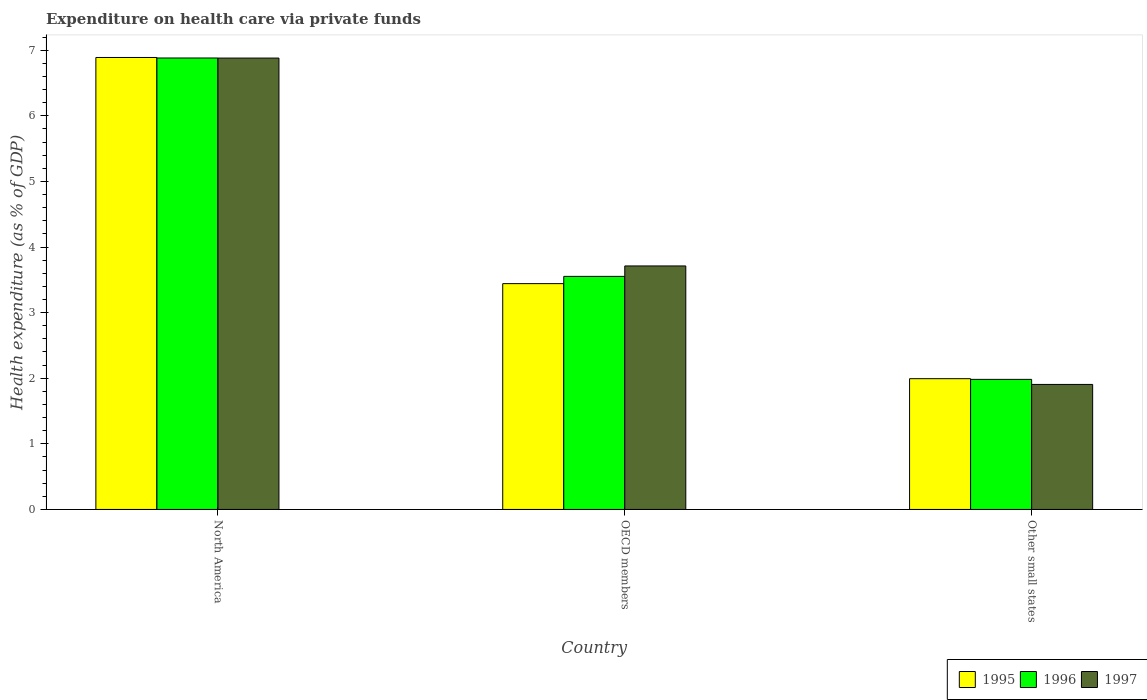How many different coloured bars are there?
Offer a terse response. 3. How many groups of bars are there?
Keep it short and to the point. 3. Are the number of bars per tick equal to the number of legend labels?
Provide a succinct answer. Yes. In how many cases, is the number of bars for a given country not equal to the number of legend labels?
Your answer should be compact. 0. What is the expenditure made on health care in 1996 in OECD members?
Offer a terse response. 3.55. Across all countries, what is the maximum expenditure made on health care in 1995?
Offer a very short reply. 6.89. Across all countries, what is the minimum expenditure made on health care in 1995?
Give a very brief answer. 1.99. In which country was the expenditure made on health care in 1995 minimum?
Ensure brevity in your answer.  Other small states. What is the total expenditure made on health care in 1997 in the graph?
Your answer should be compact. 12.5. What is the difference between the expenditure made on health care in 1995 in OECD members and that in Other small states?
Provide a succinct answer. 1.45. What is the difference between the expenditure made on health care in 1997 in North America and the expenditure made on health care in 1996 in OECD members?
Provide a succinct answer. 3.33. What is the average expenditure made on health care in 1997 per country?
Your response must be concise. 4.17. What is the difference between the expenditure made on health care of/in 1997 and expenditure made on health care of/in 1995 in Other small states?
Offer a terse response. -0.09. What is the ratio of the expenditure made on health care in 1995 in OECD members to that in Other small states?
Keep it short and to the point. 1.73. Is the expenditure made on health care in 1996 in North America less than that in Other small states?
Provide a succinct answer. No. Is the difference between the expenditure made on health care in 1997 in North America and Other small states greater than the difference between the expenditure made on health care in 1995 in North America and Other small states?
Your answer should be compact. Yes. What is the difference between the highest and the second highest expenditure made on health care in 1997?
Make the answer very short. -1.81. What is the difference between the highest and the lowest expenditure made on health care in 1997?
Provide a succinct answer. 4.97. In how many countries, is the expenditure made on health care in 1996 greater than the average expenditure made on health care in 1996 taken over all countries?
Offer a very short reply. 1. What does the 2nd bar from the left in North America represents?
Offer a very short reply. 1996. What does the 2nd bar from the right in OECD members represents?
Ensure brevity in your answer.  1996. Is it the case that in every country, the sum of the expenditure made on health care in 1995 and expenditure made on health care in 1996 is greater than the expenditure made on health care in 1997?
Your response must be concise. Yes. How many bars are there?
Give a very brief answer. 9. Are all the bars in the graph horizontal?
Ensure brevity in your answer.  No. How many countries are there in the graph?
Your answer should be compact. 3. What is the difference between two consecutive major ticks on the Y-axis?
Keep it short and to the point. 1. Are the values on the major ticks of Y-axis written in scientific E-notation?
Give a very brief answer. No. Does the graph contain any zero values?
Your answer should be compact. No. Does the graph contain grids?
Give a very brief answer. No. How are the legend labels stacked?
Your answer should be compact. Horizontal. What is the title of the graph?
Make the answer very short. Expenditure on health care via private funds. Does "2013" appear as one of the legend labels in the graph?
Keep it short and to the point. No. What is the label or title of the X-axis?
Provide a succinct answer. Country. What is the label or title of the Y-axis?
Your answer should be very brief. Health expenditure (as % of GDP). What is the Health expenditure (as % of GDP) in 1995 in North America?
Offer a very short reply. 6.89. What is the Health expenditure (as % of GDP) in 1996 in North America?
Make the answer very short. 6.88. What is the Health expenditure (as % of GDP) of 1997 in North America?
Keep it short and to the point. 6.88. What is the Health expenditure (as % of GDP) in 1995 in OECD members?
Provide a short and direct response. 3.44. What is the Health expenditure (as % of GDP) of 1996 in OECD members?
Make the answer very short. 3.55. What is the Health expenditure (as % of GDP) in 1997 in OECD members?
Your answer should be compact. 3.71. What is the Health expenditure (as % of GDP) in 1995 in Other small states?
Your answer should be compact. 1.99. What is the Health expenditure (as % of GDP) in 1996 in Other small states?
Ensure brevity in your answer.  1.98. What is the Health expenditure (as % of GDP) in 1997 in Other small states?
Provide a succinct answer. 1.91. Across all countries, what is the maximum Health expenditure (as % of GDP) of 1995?
Provide a short and direct response. 6.89. Across all countries, what is the maximum Health expenditure (as % of GDP) of 1996?
Ensure brevity in your answer.  6.88. Across all countries, what is the maximum Health expenditure (as % of GDP) in 1997?
Make the answer very short. 6.88. Across all countries, what is the minimum Health expenditure (as % of GDP) of 1995?
Give a very brief answer. 1.99. Across all countries, what is the minimum Health expenditure (as % of GDP) of 1996?
Make the answer very short. 1.98. Across all countries, what is the minimum Health expenditure (as % of GDP) of 1997?
Provide a succinct answer. 1.91. What is the total Health expenditure (as % of GDP) of 1995 in the graph?
Offer a terse response. 12.32. What is the total Health expenditure (as % of GDP) in 1996 in the graph?
Provide a succinct answer. 12.42. What is the total Health expenditure (as % of GDP) of 1997 in the graph?
Provide a short and direct response. 12.5. What is the difference between the Health expenditure (as % of GDP) in 1995 in North America and that in OECD members?
Provide a succinct answer. 3.45. What is the difference between the Health expenditure (as % of GDP) in 1996 in North America and that in OECD members?
Make the answer very short. 3.33. What is the difference between the Health expenditure (as % of GDP) of 1997 in North America and that in OECD members?
Offer a very short reply. 3.17. What is the difference between the Health expenditure (as % of GDP) in 1995 in North America and that in Other small states?
Offer a very short reply. 4.9. What is the difference between the Health expenditure (as % of GDP) in 1996 in North America and that in Other small states?
Provide a succinct answer. 4.9. What is the difference between the Health expenditure (as % of GDP) in 1997 in North America and that in Other small states?
Your response must be concise. 4.97. What is the difference between the Health expenditure (as % of GDP) of 1995 in OECD members and that in Other small states?
Your response must be concise. 1.45. What is the difference between the Health expenditure (as % of GDP) of 1996 in OECD members and that in Other small states?
Ensure brevity in your answer.  1.57. What is the difference between the Health expenditure (as % of GDP) of 1997 in OECD members and that in Other small states?
Provide a succinct answer. 1.81. What is the difference between the Health expenditure (as % of GDP) in 1995 in North America and the Health expenditure (as % of GDP) in 1996 in OECD members?
Provide a succinct answer. 3.34. What is the difference between the Health expenditure (as % of GDP) in 1995 in North America and the Health expenditure (as % of GDP) in 1997 in OECD members?
Your answer should be compact. 3.18. What is the difference between the Health expenditure (as % of GDP) of 1996 in North America and the Health expenditure (as % of GDP) of 1997 in OECD members?
Your response must be concise. 3.17. What is the difference between the Health expenditure (as % of GDP) of 1995 in North America and the Health expenditure (as % of GDP) of 1996 in Other small states?
Your answer should be compact. 4.91. What is the difference between the Health expenditure (as % of GDP) in 1995 in North America and the Health expenditure (as % of GDP) in 1997 in Other small states?
Your answer should be very brief. 4.98. What is the difference between the Health expenditure (as % of GDP) in 1996 in North America and the Health expenditure (as % of GDP) in 1997 in Other small states?
Ensure brevity in your answer.  4.98. What is the difference between the Health expenditure (as % of GDP) of 1995 in OECD members and the Health expenditure (as % of GDP) of 1996 in Other small states?
Your answer should be compact. 1.46. What is the difference between the Health expenditure (as % of GDP) of 1995 in OECD members and the Health expenditure (as % of GDP) of 1997 in Other small states?
Keep it short and to the point. 1.54. What is the difference between the Health expenditure (as % of GDP) in 1996 in OECD members and the Health expenditure (as % of GDP) in 1997 in Other small states?
Keep it short and to the point. 1.65. What is the average Health expenditure (as % of GDP) of 1995 per country?
Give a very brief answer. 4.11. What is the average Health expenditure (as % of GDP) of 1996 per country?
Keep it short and to the point. 4.14. What is the average Health expenditure (as % of GDP) in 1997 per country?
Your answer should be very brief. 4.17. What is the difference between the Health expenditure (as % of GDP) of 1995 and Health expenditure (as % of GDP) of 1996 in North America?
Offer a terse response. 0.01. What is the difference between the Health expenditure (as % of GDP) in 1995 and Health expenditure (as % of GDP) in 1997 in North America?
Offer a very short reply. 0.01. What is the difference between the Health expenditure (as % of GDP) in 1996 and Health expenditure (as % of GDP) in 1997 in North America?
Make the answer very short. 0. What is the difference between the Health expenditure (as % of GDP) in 1995 and Health expenditure (as % of GDP) in 1996 in OECD members?
Your response must be concise. -0.11. What is the difference between the Health expenditure (as % of GDP) of 1995 and Health expenditure (as % of GDP) of 1997 in OECD members?
Provide a succinct answer. -0.27. What is the difference between the Health expenditure (as % of GDP) of 1996 and Health expenditure (as % of GDP) of 1997 in OECD members?
Keep it short and to the point. -0.16. What is the difference between the Health expenditure (as % of GDP) in 1995 and Health expenditure (as % of GDP) in 1996 in Other small states?
Provide a short and direct response. 0.01. What is the difference between the Health expenditure (as % of GDP) of 1995 and Health expenditure (as % of GDP) of 1997 in Other small states?
Offer a terse response. 0.09. What is the difference between the Health expenditure (as % of GDP) of 1996 and Health expenditure (as % of GDP) of 1997 in Other small states?
Offer a terse response. 0.08. What is the ratio of the Health expenditure (as % of GDP) of 1995 in North America to that in OECD members?
Ensure brevity in your answer.  2. What is the ratio of the Health expenditure (as % of GDP) in 1996 in North America to that in OECD members?
Your response must be concise. 1.94. What is the ratio of the Health expenditure (as % of GDP) of 1997 in North America to that in OECD members?
Keep it short and to the point. 1.85. What is the ratio of the Health expenditure (as % of GDP) of 1995 in North America to that in Other small states?
Your answer should be very brief. 3.46. What is the ratio of the Health expenditure (as % of GDP) in 1996 in North America to that in Other small states?
Your answer should be compact. 3.47. What is the ratio of the Health expenditure (as % of GDP) in 1997 in North America to that in Other small states?
Ensure brevity in your answer.  3.61. What is the ratio of the Health expenditure (as % of GDP) of 1995 in OECD members to that in Other small states?
Keep it short and to the point. 1.73. What is the ratio of the Health expenditure (as % of GDP) of 1996 in OECD members to that in Other small states?
Your answer should be compact. 1.79. What is the ratio of the Health expenditure (as % of GDP) in 1997 in OECD members to that in Other small states?
Offer a terse response. 1.95. What is the difference between the highest and the second highest Health expenditure (as % of GDP) in 1995?
Make the answer very short. 3.45. What is the difference between the highest and the second highest Health expenditure (as % of GDP) of 1996?
Make the answer very short. 3.33. What is the difference between the highest and the second highest Health expenditure (as % of GDP) of 1997?
Your response must be concise. 3.17. What is the difference between the highest and the lowest Health expenditure (as % of GDP) of 1995?
Ensure brevity in your answer.  4.9. What is the difference between the highest and the lowest Health expenditure (as % of GDP) in 1996?
Provide a short and direct response. 4.9. What is the difference between the highest and the lowest Health expenditure (as % of GDP) of 1997?
Give a very brief answer. 4.97. 